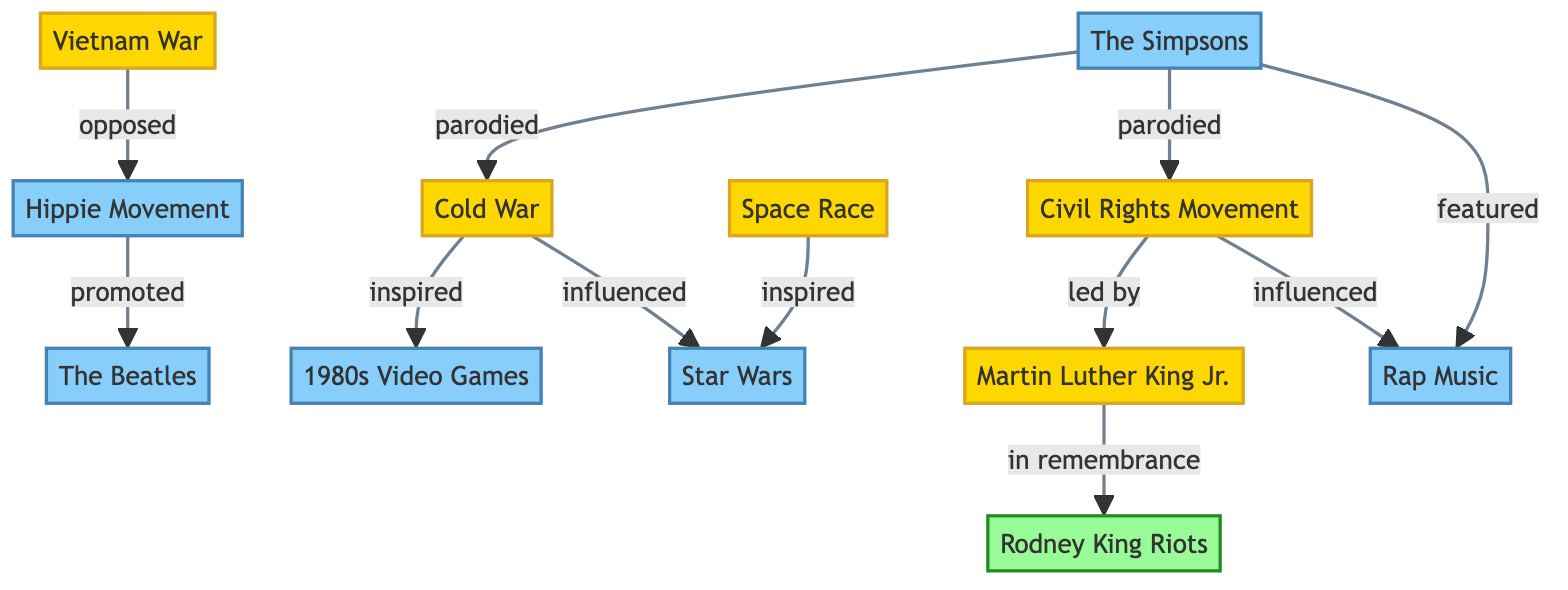What is the relationship between the Cold War and 1980s Video Games? The diagram indicates that the Cold War "inspired" 1980s Video Games. This is directly shown through the edge connecting the two nodes with the label "inspired."
Answer: inspired How many historical nodes are in the diagram? By counting the nodes categorized as historical (Cold War, Vietnam War, Space Race, Civil Rights Movement, Martin Luther King Jr.), I find there are five in total.
Answer: 5 Which event is remembered by the Rodney King Riots? The diagram shows that the Rodney King Riots are connected to Martin Luther King Jr. with the label "in remembrance." Hence, it indicates that these riots serve as a remembrance of Martin Luther King Jr.
Answer: Martin Luther King Jr What cultural element is influenced by the Civil Rights Movement? According to the diagram, the Civil Rights Movement "influenced" Rap Music. This is reflected in the edge connecting these two nodes labeled "influenced."
Answer: Rap Music How many edges connect to The Simpsons? The diagram shows that The Simpsons has three edges connecting it to other nodes (parodied connections to the Cold War and Civil Rights Movement, and a featured connection to Rap Music). Thus, it has three edges.
Answer: 3 Which historical event opposed the Hippie Movement? The connection in the diagram indicates that the Vietnam War "opposed" the Hippie Movement, which is represented by the edge with the label "opposed."
Answer: Vietnam War Which cultural element is promoted by the Hippie Movement? The diagram indicates that the Hippie Movement "promoted" The Beatles, as observed from the directed edge connecting these two nodes labeled "promoted."
Answer: The Beatles What two elements does The Simpsons parody? The diagram reveals that The Simpsons parodies both the Cold War and the Civil Rights Movement, highlighted through the connections labeled "parodied."
Answer: Cold War, Civil Rights Movement How does the Space Race connect to Star Wars? The diagram specifies that the Space Race "inspired" Star Wars, as seen through the edge linking these two nodes with the label "inspired."
Answer: inspired 